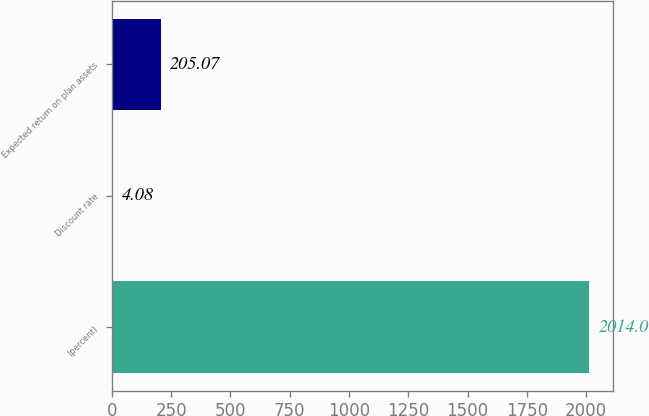Convert chart to OTSL. <chart><loc_0><loc_0><loc_500><loc_500><bar_chart><fcel>(percent)<fcel>Discount rate<fcel>Expected return on plan assets<nl><fcel>2014<fcel>4.08<fcel>205.07<nl></chart> 